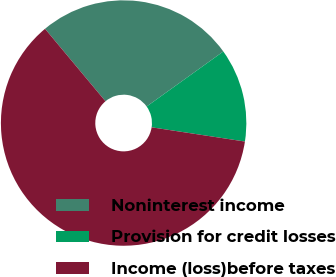Convert chart to OTSL. <chart><loc_0><loc_0><loc_500><loc_500><pie_chart><fcel>Noninterest income<fcel>Provision for credit losses<fcel>Income (loss)before taxes<nl><fcel>26.16%<fcel>12.32%<fcel>61.53%<nl></chart> 